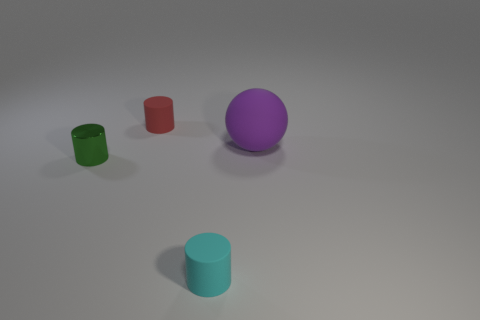There is a rubber cylinder behind the cyan rubber cylinder; what is its size?
Offer a very short reply. Small. Is the number of purple rubber spheres greater than the number of large red cubes?
Your answer should be very brief. Yes. What is the big object made of?
Offer a very short reply. Rubber. How many other objects are there of the same material as the green cylinder?
Your answer should be very brief. 0. How many big rubber blocks are there?
Give a very brief answer. 0. There is another red object that is the same shape as the small metallic thing; what is its material?
Offer a terse response. Rubber. Does the cylinder that is on the left side of the red cylinder have the same material as the cyan cylinder?
Your response must be concise. No. Is the number of matte cylinders that are in front of the rubber sphere greater than the number of small cyan matte objects in front of the cyan cylinder?
Your response must be concise. Yes. The rubber sphere is what size?
Provide a short and direct response. Large. There is a small cyan thing that is made of the same material as the purple sphere; what shape is it?
Your answer should be very brief. Cylinder. 